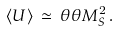Convert formula to latex. <formula><loc_0><loc_0><loc_500><loc_500>\langle U \rangle \, \simeq \, \theta \theta M _ { S } ^ { 2 } \, .</formula> 